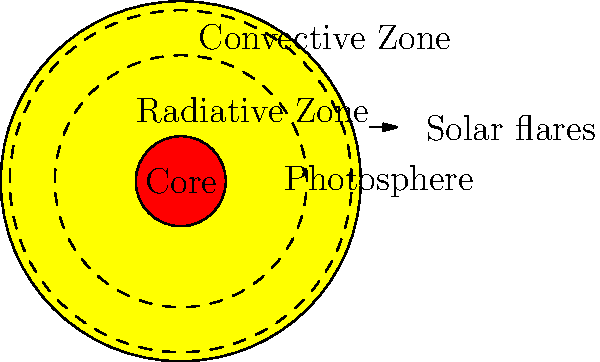As someone who welcomes newcomers to our community's astronomy club, you're often asked about basic solar structure. In the diagram, which layer of the Sun is responsible for transferring energy primarily through radiation and spans about 45% of the Sun's radius? Let's break down the structure of the Sun step-by-step:

1. The Sun has several distinct layers, each with unique characteristics and functions.

2. The innermost layer is the core, where nuclear fusion occurs. This is the hottest and densest part of the Sun.

3. Moving outward, we encounter the radiative zone. This layer is characterized by:
   - Energy transfer primarily through radiation
   - Extends from about 25% to 70% of the Sun's radius (thus spanning about 45% of the radius)
   - Very dense, preventing convection

4. The next layer is the convective zone, where energy is transferred through convection currents.

5. The visible surface of the Sun is called the photosphere, which is the outermost layer we can see.

6. Above the photosphere are the chromosphere and corona, not shown in this diagram.

In the given diagram, the radiative zone is represented by the area between the inner dashed circle (separating it from the core) and the outer dashed circle (separating it from the convective zone). This zone matches the description in the question: it transfers energy primarily through radiation and spans about 45% of the Sun's radius.
Answer: Radiative Zone 